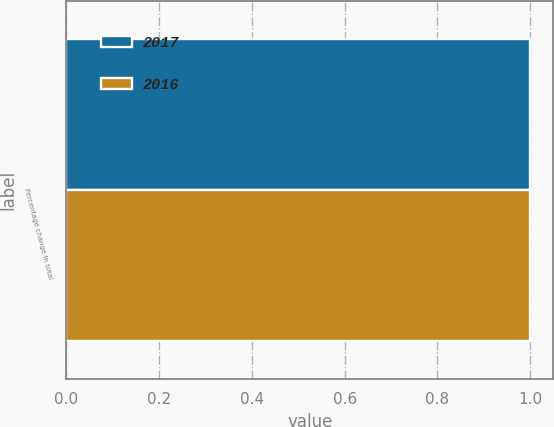Convert chart to OTSL. <chart><loc_0><loc_0><loc_500><loc_500><stacked_bar_chart><ecel><fcel>Percentage change in total<nl><fcel>2017<fcel>1<nl><fcel>2016<fcel>1<nl></chart> 